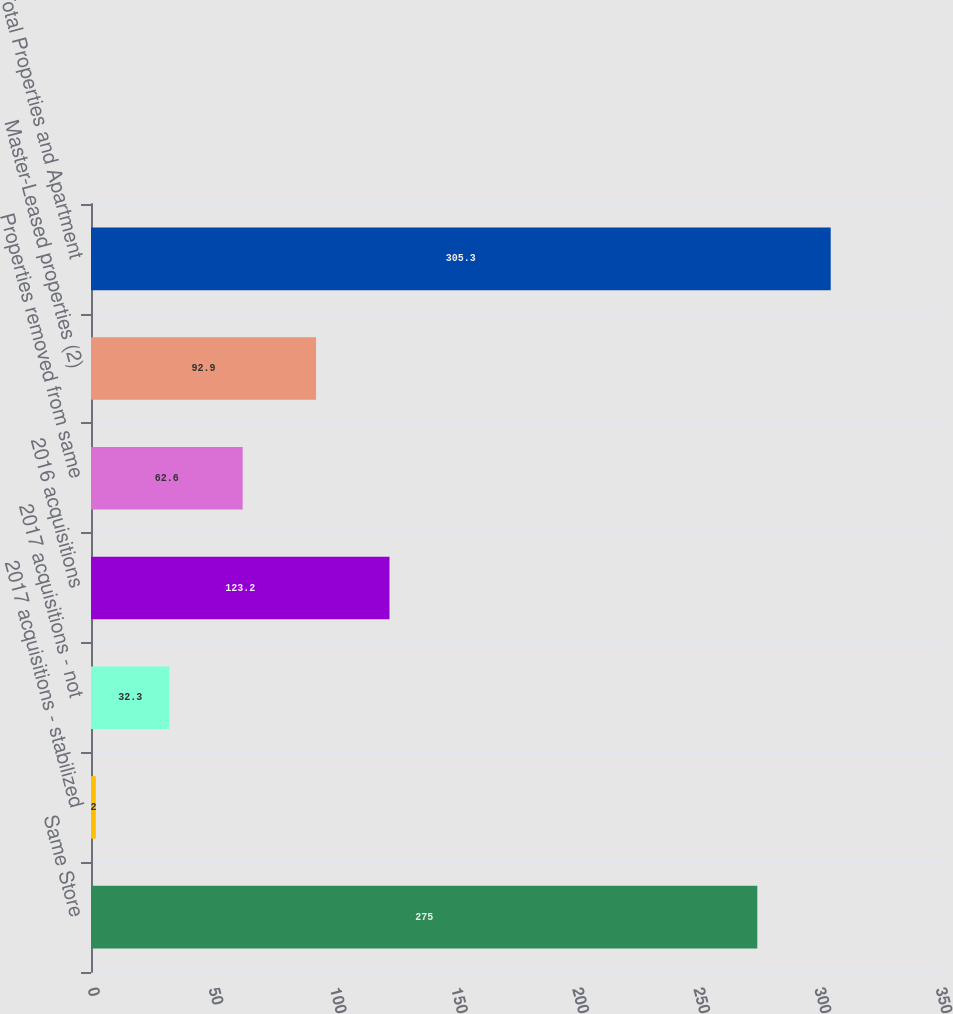Convert chart to OTSL. <chart><loc_0><loc_0><loc_500><loc_500><bar_chart><fcel>Same Store<fcel>2017 acquisitions - stabilized<fcel>2017 acquisitions - not<fcel>2016 acquisitions<fcel>Properties removed from same<fcel>Master-Leased properties (2)<fcel>Total Properties and Apartment<nl><fcel>275<fcel>2<fcel>32.3<fcel>123.2<fcel>62.6<fcel>92.9<fcel>305.3<nl></chart> 